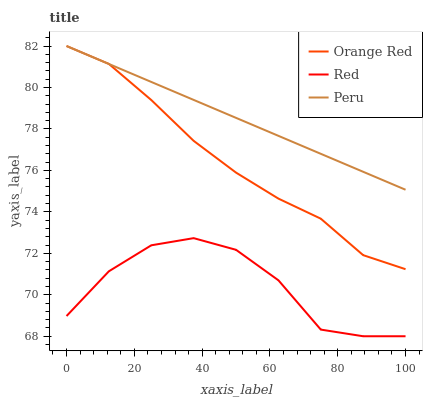Does Red have the minimum area under the curve?
Answer yes or no. Yes. Does Peru have the maximum area under the curve?
Answer yes or no. Yes. Does Orange Red have the minimum area under the curve?
Answer yes or no. No. Does Orange Red have the maximum area under the curve?
Answer yes or no. No. Is Peru the smoothest?
Answer yes or no. Yes. Is Red the roughest?
Answer yes or no. Yes. Is Orange Red the smoothest?
Answer yes or no. No. Is Orange Red the roughest?
Answer yes or no. No. Does Red have the lowest value?
Answer yes or no. Yes. Does Orange Red have the lowest value?
Answer yes or no. No. Does Orange Red have the highest value?
Answer yes or no. Yes. Does Red have the highest value?
Answer yes or no. No. Is Red less than Peru?
Answer yes or no. Yes. Is Orange Red greater than Red?
Answer yes or no. Yes. Does Orange Red intersect Peru?
Answer yes or no. Yes. Is Orange Red less than Peru?
Answer yes or no. No. Is Orange Red greater than Peru?
Answer yes or no. No. Does Red intersect Peru?
Answer yes or no. No. 